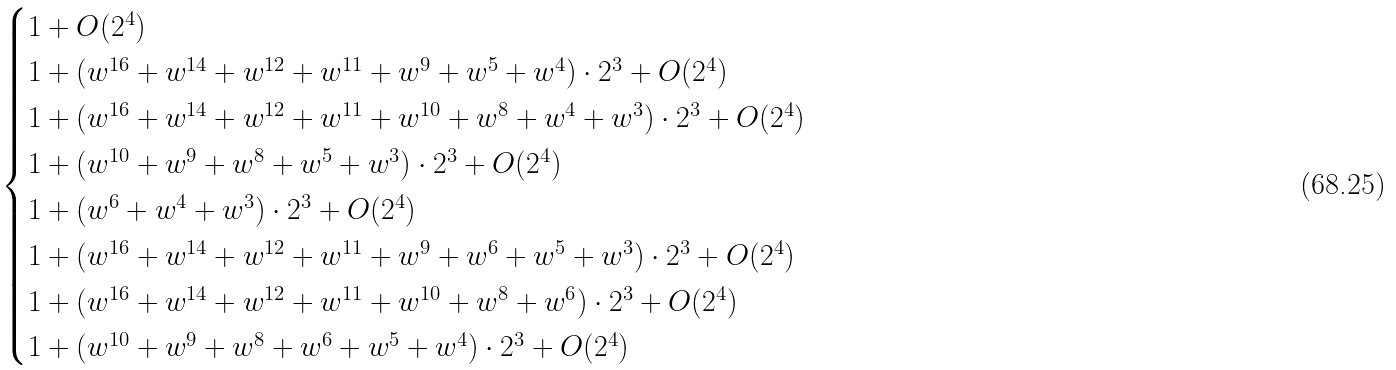Convert formula to latex. <formula><loc_0><loc_0><loc_500><loc_500>\begin{cases} 1 + O ( 2 ^ { 4 } ) \\ 1 + ( w ^ { 1 6 } + w ^ { 1 4 } + w ^ { 1 2 } + w ^ { 1 1 } + w ^ { 9 } + w ^ { 5 } + w ^ { 4 } ) \cdot 2 ^ { 3 } + O ( 2 ^ { 4 } ) \\ 1 + ( w ^ { 1 6 } + w ^ { 1 4 } + w ^ { 1 2 } + w ^ { 1 1 } + w ^ { 1 0 } + w ^ { 8 } + w ^ { 4 } + w ^ { 3 } ) \cdot 2 ^ { 3 } + O ( 2 ^ { 4 } ) \\ 1 + ( w ^ { 1 0 } + w ^ { 9 } + w ^ { 8 } + w ^ { 5 } + w ^ { 3 } ) \cdot 2 ^ { 3 } + O ( 2 ^ { 4 } ) \\ 1 + ( w ^ { 6 } + w ^ { 4 } + w ^ { 3 } ) \cdot 2 ^ { 3 } + O ( 2 ^ { 4 } ) \\ 1 + ( w ^ { 1 6 } + w ^ { 1 4 } + w ^ { 1 2 } + w ^ { 1 1 } + w ^ { 9 } + w ^ { 6 } + w ^ { 5 } + w ^ { 3 } ) \cdot 2 ^ { 3 } + O ( 2 ^ { 4 } ) \\ 1 + ( w ^ { 1 6 } + w ^ { 1 4 } + w ^ { 1 2 } + w ^ { 1 1 } + w ^ { 1 0 } + w ^ { 8 } + w ^ { 6 } ) \cdot 2 ^ { 3 } + O ( 2 ^ { 4 } ) \\ 1 + ( w ^ { 1 0 } + w ^ { 9 } + w ^ { 8 } + w ^ { 6 } + w ^ { 5 } + w ^ { 4 } ) \cdot 2 ^ { 3 } + O ( 2 ^ { 4 } ) \end{cases}</formula> 